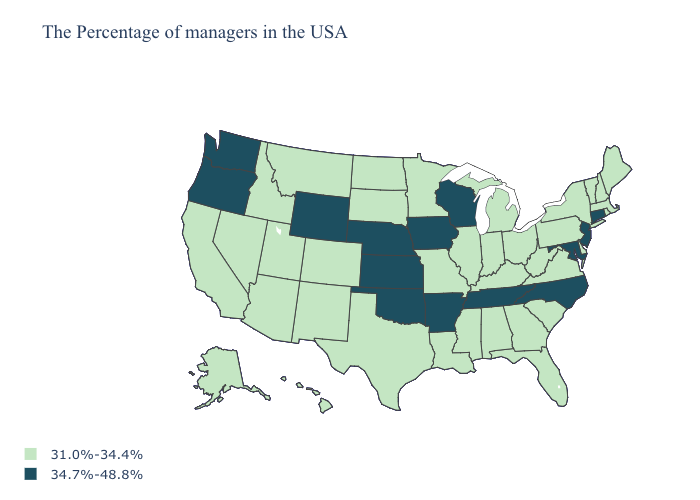What is the value of Alaska?
Quick response, please. 31.0%-34.4%. Name the states that have a value in the range 31.0%-34.4%?
Keep it brief. Maine, Massachusetts, Rhode Island, New Hampshire, Vermont, New York, Delaware, Pennsylvania, Virginia, South Carolina, West Virginia, Ohio, Florida, Georgia, Michigan, Kentucky, Indiana, Alabama, Illinois, Mississippi, Louisiana, Missouri, Minnesota, Texas, South Dakota, North Dakota, Colorado, New Mexico, Utah, Montana, Arizona, Idaho, Nevada, California, Alaska, Hawaii. Name the states that have a value in the range 34.7%-48.8%?
Write a very short answer. Connecticut, New Jersey, Maryland, North Carolina, Tennessee, Wisconsin, Arkansas, Iowa, Kansas, Nebraska, Oklahoma, Wyoming, Washington, Oregon. What is the highest value in states that border Oregon?
Answer briefly. 34.7%-48.8%. Which states hav the highest value in the MidWest?
Answer briefly. Wisconsin, Iowa, Kansas, Nebraska. What is the highest value in the USA?
Keep it brief. 34.7%-48.8%. Which states hav the highest value in the MidWest?
Short answer required. Wisconsin, Iowa, Kansas, Nebraska. What is the lowest value in the MidWest?
Write a very short answer. 31.0%-34.4%. Name the states that have a value in the range 34.7%-48.8%?
Be succinct. Connecticut, New Jersey, Maryland, North Carolina, Tennessee, Wisconsin, Arkansas, Iowa, Kansas, Nebraska, Oklahoma, Wyoming, Washington, Oregon. What is the highest value in the South ?
Keep it brief. 34.7%-48.8%. Is the legend a continuous bar?
Quick response, please. No. Name the states that have a value in the range 31.0%-34.4%?
Short answer required. Maine, Massachusetts, Rhode Island, New Hampshire, Vermont, New York, Delaware, Pennsylvania, Virginia, South Carolina, West Virginia, Ohio, Florida, Georgia, Michigan, Kentucky, Indiana, Alabama, Illinois, Mississippi, Louisiana, Missouri, Minnesota, Texas, South Dakota, North Dakota, Colorado, New Mexico, Utah, Montana, Arizona, Idaho, Nevada, California, Alaska, Hawaii. What is the lowest value in the USA?
Quick response, please. 31.0%-34.4%. Does New Hampshire have the same value as Louisiana?
Keep it brief. Yes. Which states hav the highest value in the South?
Write a very short answer. Maryland, North Carolina, Tennessee, Arkansas, Oklahoma. 